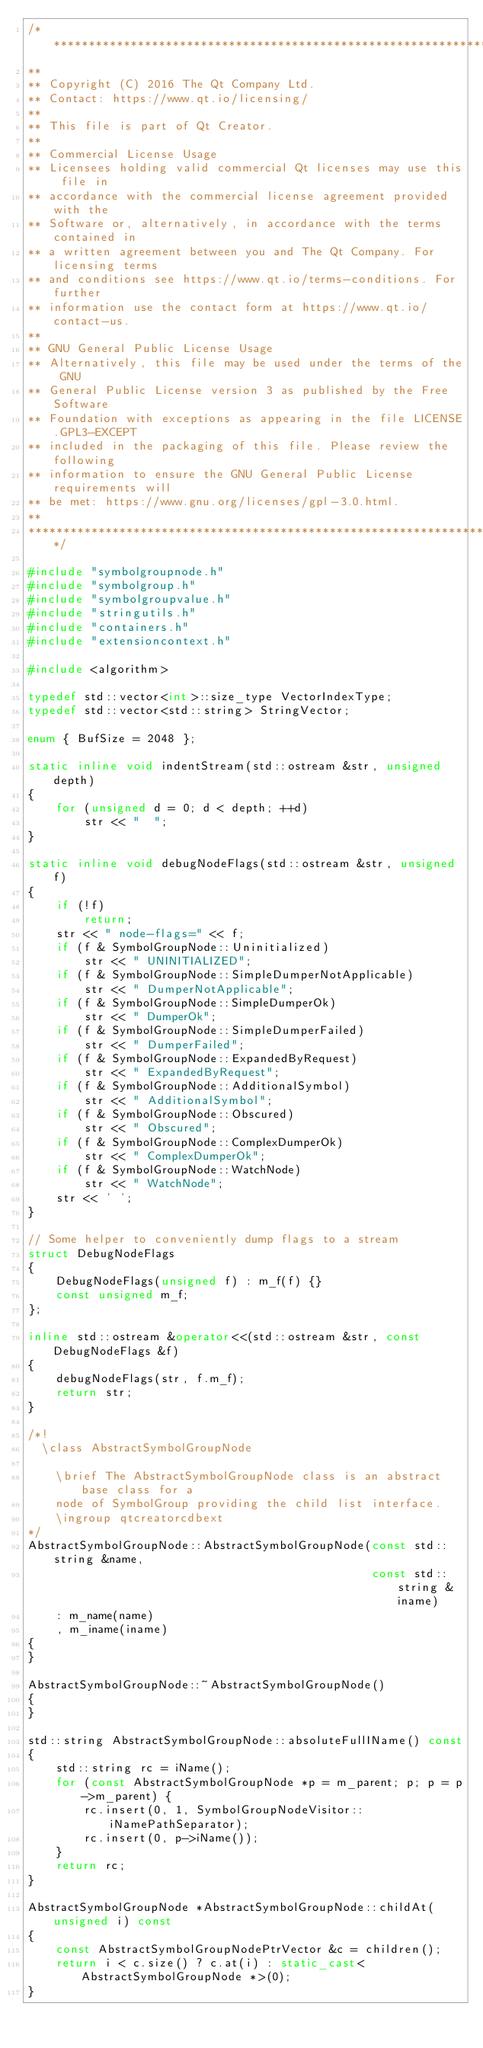<code> <loc_0><loc_0><loc_500><loc_500><_C++_>/****************************************************************************
**
** Copyright (C) 2016 The Qt Company Ltd.
** Contact: https://www.qt.io/licensing/
**
** This file is part of Qt Creator.
**
** Commercial License Usage
** Licensees holding valid commercial Qt licenses may use this file in
** accordance with the commercial license agreement provided with the
** Software or, alternatively, in accordance with the terms contained in
** a written agreement between you and The Qt Company. For licensing terms
** and conditions see https://www.qt.io/terms-conditions. For further
** information use the contact form at https://www.qt.io/contact-us.
**
** GNU General Public License Usage
** Alternatively, this file may be used under the terms of the GNU
** General Public License version 3 as published by the Free Software
** Foundation with exceptions as appearing in the file LICENSE.GPL3-EXCEPT
** included in the packaging of this file. Please review the following
** information to ensure the GNU General Public License requirements will
** be met: https://www.gnu.org/licenses/gpl-3.0.html.
**
****************************************************************************/

#include "symbolgroupnode.h"
#include "symbolgroup.h"
#include "symbolgroupvalue.h"
#include "stringutils.h"
#include "containers.h"
#include "extensioncontext.h"

#include <algorithm>

typedef std::vector<int>::size_type VectorIndexType;
typedef std::vector<std::string> StringVector;

enum { BufSize = 2048 };

static inline void indentStream(std::ostream &str, unsigned depth)
{
    for (unsigned d = 0; d < depth; ++d)
        str << "  ";
}

static inline void debugNodeFlags(std::ostream &str, unsigned f)
{
    if (!f)
        return;
    str << " node-flags=" << f;
    if (f & SymbolGroupNode::Uninitialized)
        str << " UNINITIALIZED";
    if (f & SymbolGroupNode::SimpleDumperNotApplicable)
        str << " DumperNotApplicable";
    if (f & SymbolGroupNode::SimpleDumperOk)
        str << " DumperOk";
    if (f & SymbolGroupNode::SimpleDumperFailed)
        str << " DumperFailed";
    if (f & SymbolGroupNode::ExpandedByRequest)
        str << " ExpandedByRequest";
    if (f & SymbolGroupNode::AdditionalSymbol)
        str << " AdditionalSymbol";
    if (f & SymbolGroupNode::Obscured)
        str << " Obscured";
    if (f & SymbolGroupNode::ComplexDumperOk)
        str << " ComplexDumperOk";
    if (f & SymbolGroupNode::WatchNode)
        str << " WatchNode";
    str << ' ';
}

// Some helper to conveniently dump flags to a stream
struct DebugNodeFlags
{
    DebugNodeFlags(unsigned f) : m_f(f) {}
    const unsigned m_f;
};

inline std::ostream &operator<<(std::ostream &str, const DebugNodeFlags &f)
{
    debugNodeFlags(str, f.m_f);
    return str;
}

/*!
  \class AbstractSymbolGroupNode

    \brief The AbstractSymbolGroupNode class is an abstract base class for a
    node of SymbolGroup providing the child list interface.
    \ingroup qtcreatorcdbext
*/
AbstractSymbolGroupNode::AbstractSymbolGroupNode(const std::string &name,
                                                 const std::string &iname)
    : m_name(name)
    , m_iname(iname)
{
}

AbstractSymbolGroupNode::~AbstractSymbolGroupNode()
{
}

std::string AbstractSymbolGroupNode::absoluteFullIName() const
{
    std::string rc = iName();
    for (const AbstractSymbolGroupNode *p = m_parent; p; p = p->m_parent) {
        rc.insert(0, 1, SymbolGroupNodeVisitor::iNamePathSeparator);
        rc.insert(0, p->iName());
    }
    return rc;
}

AbstractSymbolGroupNode *AbstractSymbolGroupNode::childAt(unsigned i) const
{
    const AbstractSymbolGroupNodePtrVector &c = children();
    return i < c.size() ? c.at(i) : static_cast<AbstractSymbolGroupNode *>(0);
}
</code> 